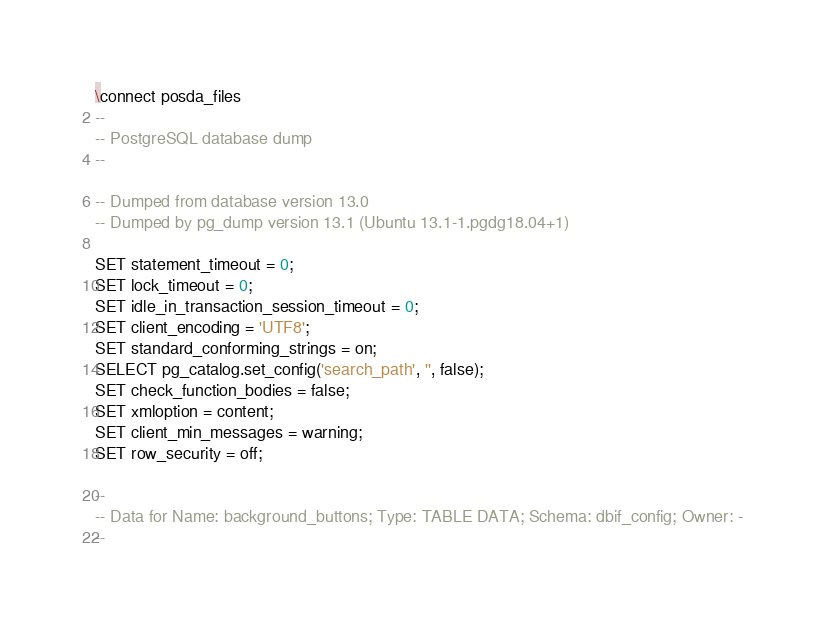<code> <loc_0><loc_0><loc_500><loc_500><_SQL_>\connect posda_files
--
-- PostgreSQL database dump
--

-- Dumped from database version 13.0
-- Dumped by pg_dump version 13.1 (Ubuntu 13.1-1.pgdg18.04+1)

SET statement_timeout = 0;
SET lock_timeout = 0;
SET idle_in_transaction_session_timeout = 0;
SET client_encoding = 'UTF8';
SET standard_conforming_strings = on;
SELECT pg_catalog.set_config('search_path', '', false);
SET check_function_bodies = false;
SET xmloption = content;
SET client_min_messages = warning;
SET row_security = off;

--
-- Data for Name: background_buttons; Type: TABLE DATA; Schema: dbif_config; Owner: -
--
</code> 